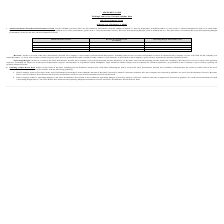From Ringcentral's financial document, When does each respective quarterly performance period end? The document contains multiple relevant values: March 31, June 30, September 30, December 31. From the document: "ds, ending on March 31, June 30, September 30 and December 31, 2019 (each, a “2019 Performance Period”). For each of the four 2019 Performance Periods..." Also, How is net revenue defined? gross sales less any pertinent discounts, refunds or other contra-revenue amounts, as presented on the Company’s press releases reporting its quarterly financial results.. The document states: "ended December 31, 2018. Net revenue is defined as gross sales less any pertinent discounts, refunds or other contra-revenue amounts, as presented on ..." Also, What are the respective operating margin performance goal in Q1 and Q2? The document shows two values: 8.1% and 8.3%. From the document: "Q2 $211.7 8.3% Q1 $199.5 8.1%..." Also, can you calculate: What is the company's average revenue performance goal in the first two quarters of 2019? To answer this question, I need to perform calculations using the financial data. The calculation is: (199.5 + 211.7)/2 , which equals 205.6 (in millions). This is based on the information: "Q2 $211.7 8.3% Q1 $199.5 8.1%..." The key data points involved are: 199.5, 211.7. Also, can you calculate: What is the company's average revenue performance goal in the last two quarters of 2019? To answer this question, I need to perform calculations using the financial data. The calculation is: (227.3 + 243.2)/2 , which equals 235.25 (in millions). This is based on the information: "Q3 $227.3 9.6% Q4 $243.2 10.8%..." The key data points involved are: 227.3, 243.2. Also, can you calculate: What is the value of the company's Q1 revenue performance goal as a percentage of its Q2 performance goal? Based on the calculation: 199.5/211.7 , the result is 94.24 (percentage). This is based on the information: "Q2 $211.7 8.3% Q1 $199.5 8.1%..." The key data points involved are: 199.5, 211.7. 